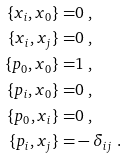<formula> <loc_0><loc_0><loc_500><loc_500>\{ x _ { i } , x _ { 0 } \} = & 0 \ , \\ \{ x _ { i } , x _ { j } \} = & 0 \ , \\ \{ p _ { 0 } , x _ { 0 } \} = & 1 \ , \\ \{ p _ { i } , x _ { 0 } \} = & 0 \ , \\ \{ p _ { 0 } , x _ { i } \} = & 0 \ , \\ \{ p _ { i } , x _ { j } \} = & - \delta _ { i j } \ .</formula> 